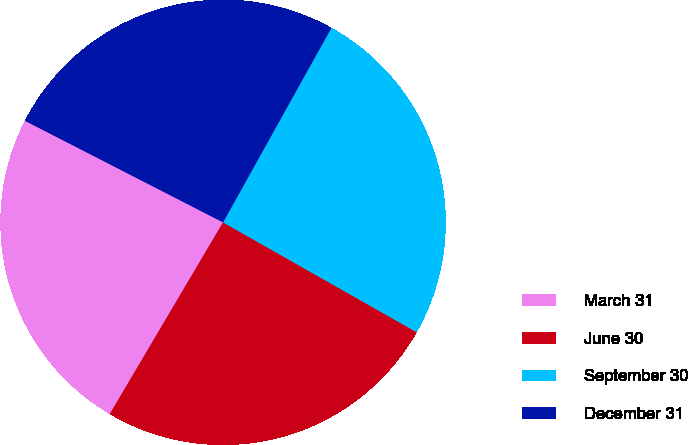<chart> <loc_0><loc_0><loc_500><loc_500><pie_chart><fcel>March 31<fcel>June 30<fcel>September 30<fcel>December 31<nl><fcel>24.05%<fcel>25.28%<fcel>25.13%<fcel>25.55%<nl></chart> 